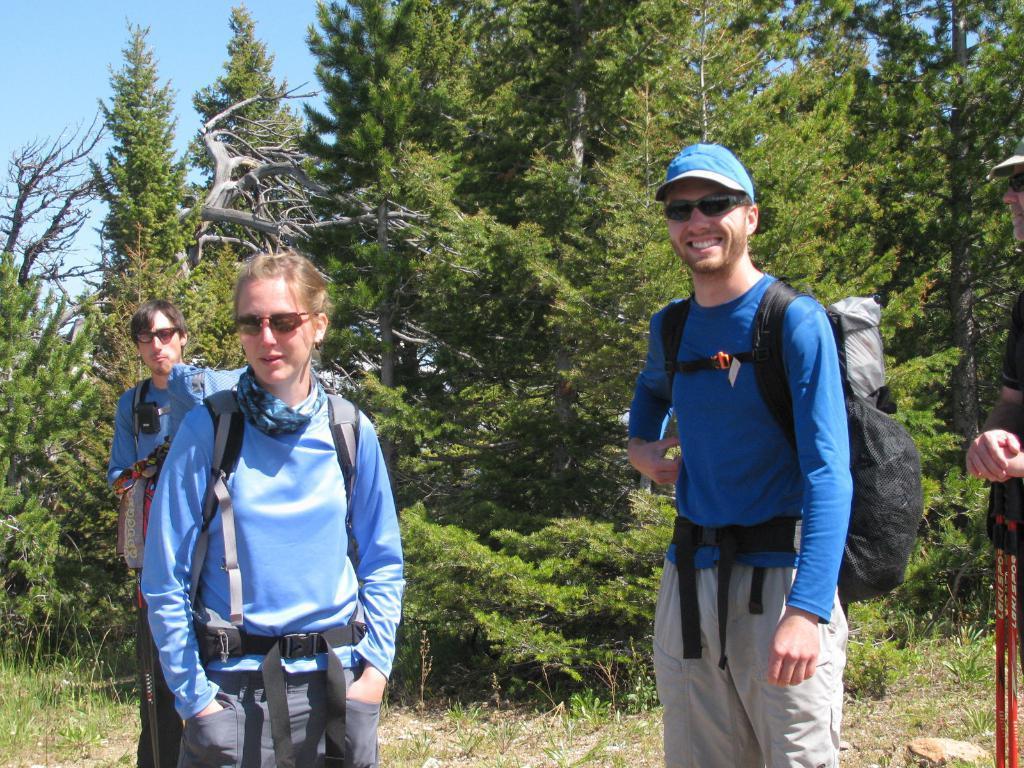How would you summarize this image in a sentence or two? In this image there are a few people standing on the surface, one of them is smiling and the other one is holding some objects, in the background there are trees and the sky. 